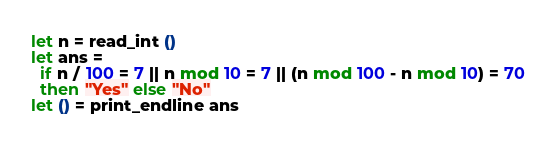<code> <loc_0><loc_0><loc_500><loc_500><_OCaml_>let n = read_int ()
let ans =
  if n / 100 = 7 || n mod 10 = 7 || (n mod 100 - n mod 10) = 70
  then "Yes" else "No"
let () = print_endline ans</code> 